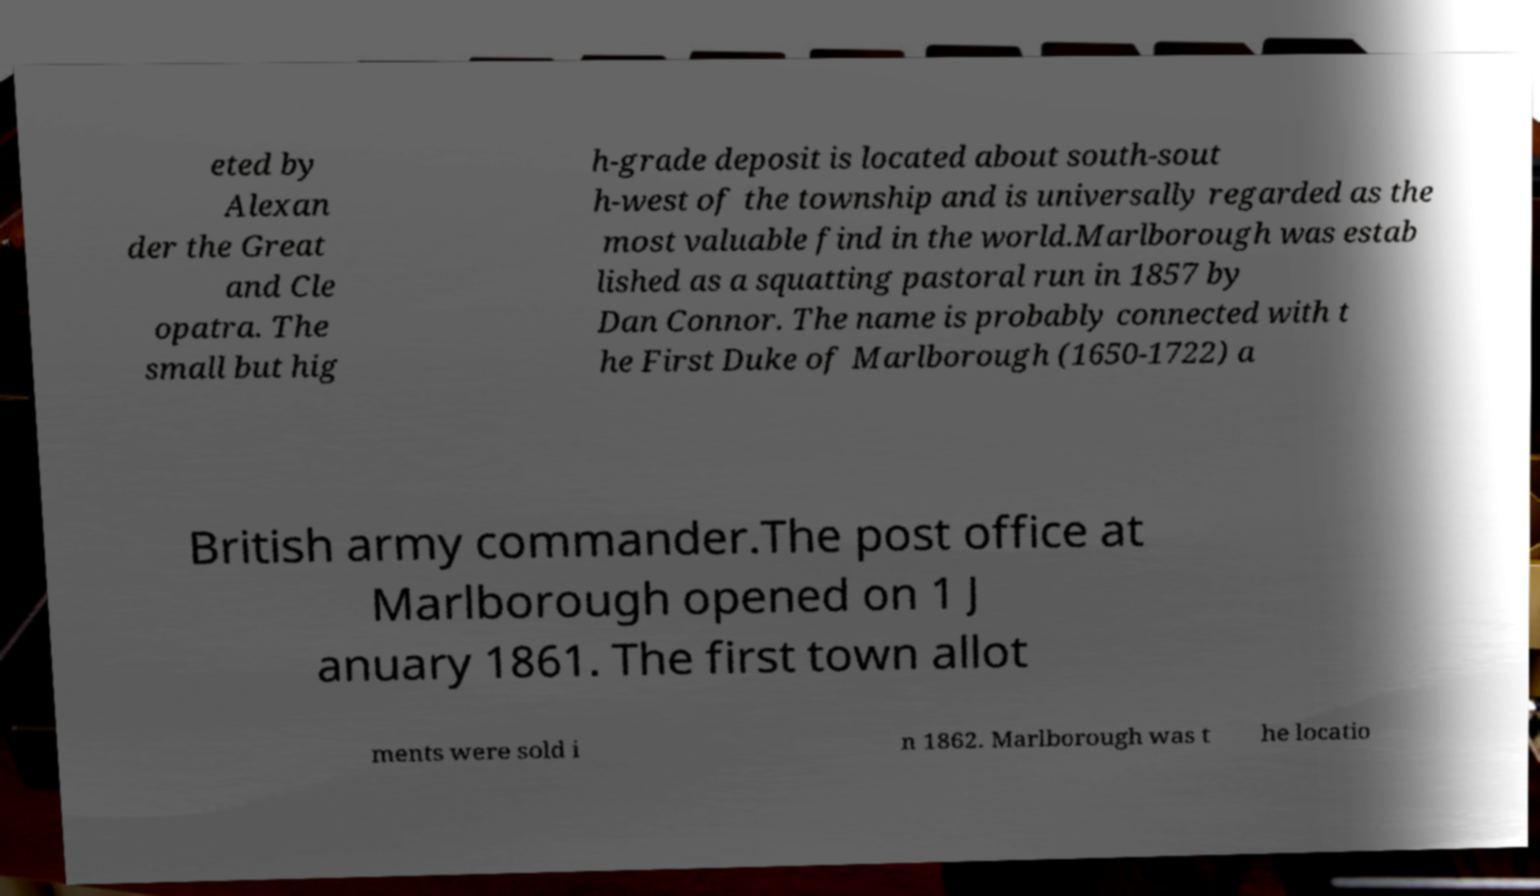What messages or text are displayed in this image? I need them in a readable, typed format. eted by Alexan der the Great and Cle opatra. The small but hig h-grade deposit is located about south-sout h-west of the township and is universally regarded as the most valuable find in the world.Marlborough was estab lished as a squatting pastoral run in 1857 by Dan Connor. The name is probably connected with t he First Duke of Marlborough (1650-1722) a British army commander.The post office at Marlborough opened on 1 J anuary 1861. The first town allot ments were sold i n 1862. Marlborough was t he locatio 